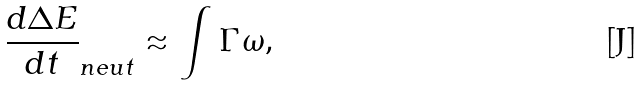Convert formula to latex. <formula><loc_0><loc_0><loc_500><loc_500>\frac { d \Delta E } { d t } _ { n e u t } \approx \int \Gamma \omega ,</formula> 